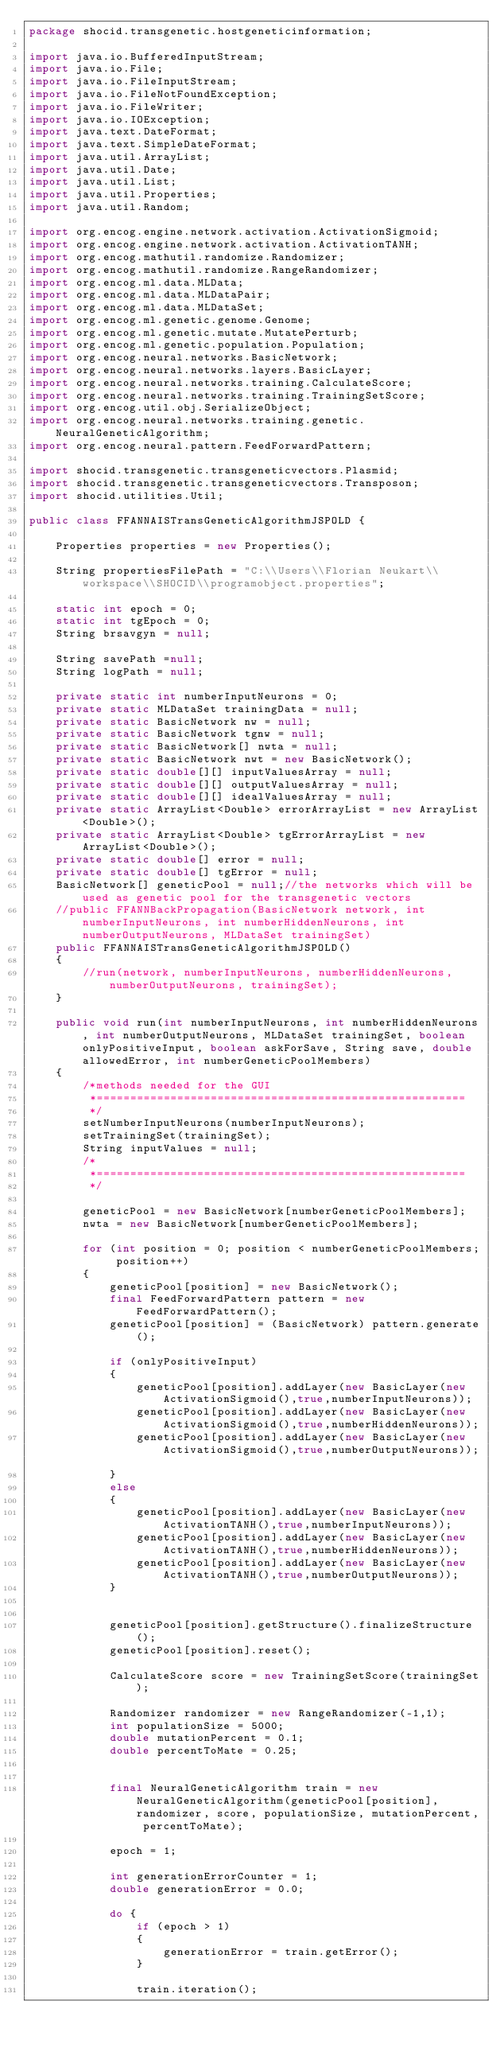<code> <loc_0><loc_0><loc_500><loc_500><_Java_>package shocid.transgenetic.hostgeneticinformation;

import java.io.BufferedInputStream;
import java.io.File;
import java.io.FileInputStream;
import java.io.FileNotFoundException;
import java.io.FileWriter;
import java.io.IOException;
import java.text.DateFormat;
import java.text.SimpleDateFormat;
import java.util.ArrayList;
import java.util.Date;
import java.util.List;
import java.util.Properties;
import java.util.Random;

import org.encog.engine.network.activation.ActivationSigmoid;
import org.encog.engine.network.activation.ActivationTANH;
import org.encog.mathutil.randomize.Randomizer;
import org.encog.mathutil.randomize.RangeRandomizer;
import org.encog.ml.data.MLData;
import org.encog.ml.data.MLDataPair;
import org.encog.ml.data.MLDataSet;
import org.encog.ml.genetic.genome.Genome;
import org.encog.ml.genetic.mutate.MutatePerturb;
import org.encog.ml.genetic.population.Population;
import org.encog.neural.networks.BasicNetwork;
import org.encog.neural.networks.layers.BasicLayer;
import org.encog.neural.networks.training.CalculateScore;
import org.encog.neural.networks.training.TrainingSetScore;
import org.encog.util.obj.SerializeObject;
import org.encog.neural.networks.training.genetic.NeuralGeneticAlgorithm;
import org.encog.neural.pattern.FeedForwardPattern;

import shocid.transgenetic.transgeneticvectors.Plasmid;
import shocid.transgenetic.transgeneticvectors.Transposon;
import shocid.utilities.Util;

public class FFANNAISTransGeneticAlgorithmJSPOLD {

	Properties properties = new Properties();

	String propertiesFilePath = "C:\\Users\\Florian Neukart\\workspace\\SHOCID\\programobject.properties";

	static int epoch = 0;
	static int tgEpoch = 0;
	String brsavgyn = null;

	String savePath =null;
	String logPath = null;

	private static int numberInputNeurons = 0;
	private static MLDataSet trainingData = null;
	private static BasicNetwork nw = null;
	private static BasicNetwork tgnw = null;
	private static BasicNetwork[] nwta = null;
	private static BasicNetwork nwt = new BasicNetwork();
	private static double[][] inputValuesArray = null;
	private static double[][] outputValuesArray = null;
	private static double[][] idealValuesArray = null;
	private static ArrayList<Double> errorArrayList = new ArrayList<Double>();
	private static ArrayList<Double> tgErrorArrayList = new ArrayList<Double>();
	private static double[] error = null;
	private static double[] tgError = null;
	BasicNetwork[] geneticPool = null;//the networks which will be used as genetic pool for the transgenetic vectors
	//public FFANNBackPropagation(BasicNetwork network, int numberInputNeurons, int numberHiddenNeurons, int numberOutputNeurons, MLDataSet trainingSet)
	public FFANNAISTransGeneticAlgorithmJSPOLD()
	{
		//run(network, numberInputNeurons, numberHiddenNeurons, numberOutputNeurons, trainingSet);
	}

	public void run(int numberInputNeurons, int numberHiddenNeurons, int numberOutputNeurons, MLDataSet trainingSet, boolean onlyPositiveInput, boolean askForSave, String save, double allowedError, int numberGeneticPoolMembers)
	{
		/*methods needed for the GUI
		 *=======================================================
		 */
		setNumberInputNeurons(numberInputNeurons);
		setTrainingSet(trainingSet);
		String inputValues = null;
		/*
		 *======================================================= 
		 */

		geneticPool = new BasicNetwork[numberGeneticPoolMembers];
		nwta = new BasicNetwork[numberGeneticPoolMembers];

		for (int position = 0; position < numberGeneticPoolMembers; position++)
		{
			geneticPool[position] = new BasicNetwork();
			final FeedForwardPattern pattern = new FeedForwardPattern();
			geneticPool[position] = (BasicNetwork) pattern.generate();

			if (onlyPositiveInput)
			{
				geneticPool[position].addLayer(new BasicLayer(new ActivationSigmoid(),true,numberInputNeurons));
				geneticPool[position].addLayer(new BasicLayer(new ActivationSigmoid(),true,numberHiddenNeurons));
				geneticPool[position].addLayer(new BasicLayer(new ActivationSigmoid(),true,numberOutputNeurons));	
			}
			else
			{
				geneticPool[position].addLayer(new BasicLayer(new ActivationTANH(),true,numberInputNeurons));
				geneticPool[position].addLayer(new BasicLayer(new ActivationTANH(),true,numberHiddenNeurons));
				geneticPool[position].addLayer(new BasicLayer(new ActivationTANH(),true,numberOutputNeurons));
			}

			
			geneticPool[position].getStructure().finalizeStructure();
			geneticPool[position].reset();

			CalculateScore score = new TrainingSetScore(trainingSet);

			Randomizer randomizer = new RangeRandomizer(-1,1);
			int populationSize = 5000;
			double mutationPercent = 0.1;
			double percentToMate = 0.25;


			final NeuralGeneticAlgorithm train = new NeuralGeneticAlgorithm(geneticPool[position], randomizer, score, populationSize, mutationPercent, percentToMate);

			epoch = 1;

			int generationErrorCounter = 1;
			double generationError = 0.0;

			do {
				if (epoch > 1)
				{
					generationError = train.getError();
				}

				train.iteration();</code> 